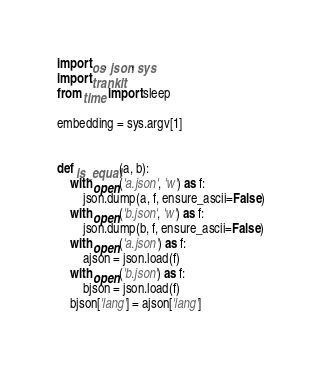Convert code to text. <code><loc_0><loc_0><loc_500><loc_500><_Python_>import os, json, sys
import trankit
from time import sleep

embedding = sys.argv[1]


def is_equal(a, b):
    with open('a.json', 'w') as f:
        json.dump(a, f, ensure_ascii=False)
    with open('b.json', 'w') as f:
        json.dump(b, f, ensure_ascii=False)
    with open('a.json') as f:
        ajson = json.load(f)
    with open('b.json') as f:
        bjson = json.load(f)
    bjson['lang'] = ajson['lang']</code> 